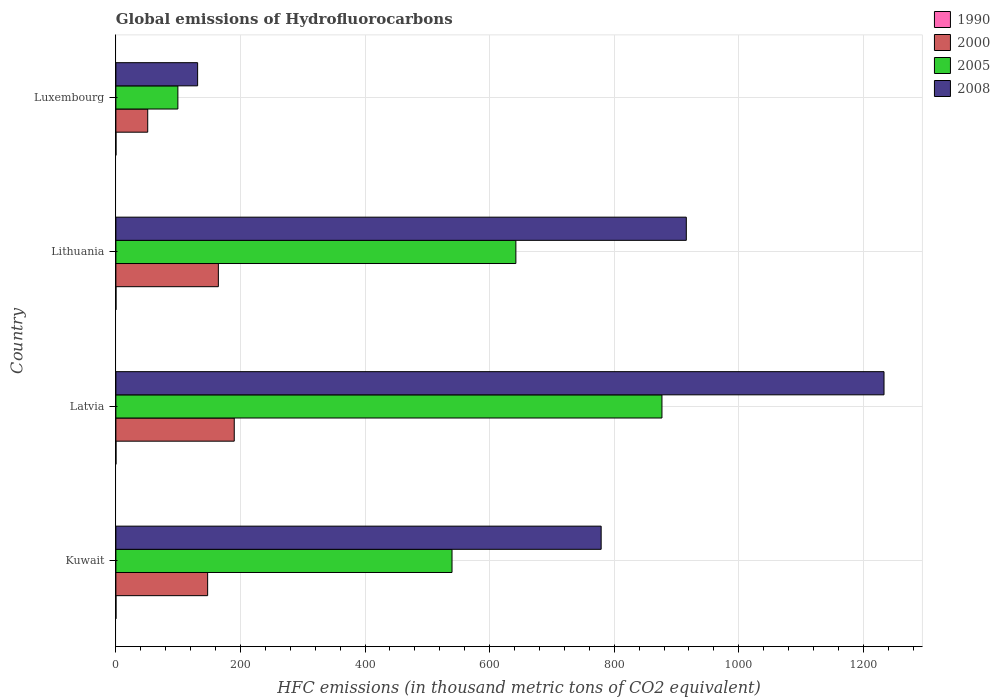How many different coloured bars are there?
Offer a very short reply. 4. Are the number of bars per tick equal to the number of legend labels?
Your answer should be very brief. Yes. How many bars are there on the 4th tick from the bottom?
Provide a short and direct response. 4. What is the label of the 3rd group of bars from the top?
Offer a terse response. Latvia. What is the global emissions of Hydrofluorocarbons in 2008 in Lithuania?
Offer a very short reply. 915.7. In which country was the global emissions of Hydrofluorocarbons in 1990 maximum?
Keep it short and to the point. Kuwait. In which country was the global emissions of Hydrofluorocarbons in 2000 minimum?
Your answer should be very brief. Luxembourg. What is the total global emissions of Hydrofluorocarbons in 2000 in the graph?
Keep it short and to the point. 552.9. What is the difference between the global emissions of Hydrofluorocarbons in 2000 in Lithuania and that in Luxembourg?
Make the answer very short. 113.4. What is the difference between the global emissions of Hydrofluorocarbons in 1990 in Kuwait and the global emissions of Hydrofluorocarbons in 2008 in Luxembourg?
Ensure brevity in your answer.  -131.1. What is the average global emissions of Hydrofluorocarbons in 1990 per country?
Keep it short and to the point. 0.1. What is the difference between the global emissions of Hydrofluorocarbons in 2008 and global emissions of Hydrofluorocarbons in 2005 in Lithuania?
Provide a succinct answer. 273.6. In how many countries, is the global emissions of Hydrofluorocarbons in 2008 greater than 240 thousand metric tons?
Your response must be concise. 3. What is the ratio of the global emissions of Hydrofluorocarbons in 2000 in Kuwait to that in Latvia?
Offer a very short reply. 0.78. Is the global emissions of Hydrofluorocarbons in 2000 in Latvia less than that in Luxembourg?
Keep it short and to the point. No. Is the difference between the global emissions of Hydrofluorocarbons in 2008 in Lithuania and Luxembourg greater than the difference between the global emissions of Hydrofluorocarbons in 2005 in Lithuania and Luxembourg?
Keep it short and to the point. Yes. What is the difference between the highest and the second highest global emissions of Hydrofluorocarbons in 2008?
Offer a very short reply. 317.4. What is the difference between the highest and the lowest global emissions of Hydrofluorocarbons in 2008?
Your answer should be very brief. 1101.9. In how many countries, is the global emissions of Hydrofluorocarbons in 1990 greater than the average global emissions of Hydrofluorocarbons in 1990 taken over all countries?
Offer a terse response. 0. Is the sum of the global emissions of Hydrofluorocarbons in 2005 in Latvia and Lithuania greater than the maximum global emissions of Hydrofluorocarbons in 2000 across all countries?
Ensure brevity in your answer.  Yes. What does the 1st bar from the bottom in Kuwait represents?
Offer a terse response. 1990. How many countries are there in the graph?
Provide a short and direct response. 4. What is the difference between two consecutive major ticks on the X-axis?
Your answer should be very brief. 200. Are the values on the major ticks of X-axis written in scientific E-notation?
Provide a succinct answer. No. Does the graph contain any zero values?
Ensure brevity in your answer.  No. Does the graph contain grids?
Keep it short and to the point. Yes. How many legend labels are there?
Make the answer very short. 4. What is the title of the graph?
Ensure brevity in your answer.  Global emissions of Hydrofluorocarbons. What is the label or title of the X-axis?
Provide a succinct answer. HFC emissions (in thousand metric tons of CO2 equivalent). What is the HFC emissions (in thousand metric tons of CO2 equivalent) in 1990 in Kuwait?
Make the answer very short. 0.1. What is the HFC emissions (in thousand metric tons of CO2 equivalent) of 2000 in Kuwait?
Provide a short and direct response. 147.3. What is the HFC emissions (in thousand metric tons of CO2 equivalent) in 2005 in Kuwait?
Offer a terse response. 539.6. What is the HFC emissions (in thousand metric tons of CO2 equivalent) of 2008 in Kuwait?
Give a very brief answer. 779. What is the HFC emissions (in thousand metric tons of CO2 equivalent) of 2000 in Latvia?
Your answer should be very brief. 190. What is the HFC emissions (in thousand metric tons of CO2 equivalent) of 2005 in Latvia?
Keep it short and to the point. 876.6. What is the HFC emissions (in thousand metric tons of CO2 equivalent) of 2008 in Latvia?
Offer a terse response. 1233.1. What is the HFC emissions (in thousand metric tons of CO2 equivalent) in 1990 in Lithuania?
Provide a short and direct response. 0.1. What is the HFC emissions (in thousand metric tons of CO2 equivalent) of 2000 in Lithuania?
Offer a terse response. 164.5. What is the HFC emissions (in thousand metric tons of CO2 equivalent) in 2005 in Lithuania?
Provide a short and direct response. 642.1. What is the HFC emissions (in thousand metric tons of CO2 equivalent) in 2008 in Lithuania?
Provide a succinct answer. 915.7. What is the HFC emissions (in thousand metric tons of CO2 equivalent) in 2000 in Luxembourg?
Keep it short and to the point. 51.1. What is the HFC emissions (in thousand metric tons of CO2 equivalent) of 2005 in Luxembourg?
Your response must be concise. 99.5. What is the HFC emissions (in thousand metric tons of CO2 equivalent) of 2008 in Luxembourg?
Provide a succinct answer. 131.2. Across all countries, what is the maximum HFC emissions (in thousand metric tons of CO2 equivalent) in 1990?
Give a very brief answer. 0.1. Across all countries, what is the maximum HFC emissions (in thousand metric tons of CO2 equivalent) in 2000?
Keep it short and to the point. 190. Across all countries, what is the maximum HFC emissions (in thousand metric tons of CO2 equivalent) of 2005?
Keep it short and to the point. 876.6. Across all countries, what is the maximum HFC emissions (in thousand metric tons of CO2 equivalent) in 2008?
Provide a succinct answer. 1233.1. Across all countries, what is the minimum HFC emissions (in thousand metric tons of CO2 equivalent) in 2000?
Your answer should be very brief. 51.1. Across all countries, what is the minimum HFC emissions (in thousand metric tons of CO2 equivalent) of 2005?
Give a very brief answer. 99.5. Across all countries, what is the minimum HFC emissions (in thousand metric tons of CO2 equivalent) in 2008?
Your answer should be compact. 131.2. What is the total HFC emissions (in thousand metric tons of CO2 equivalent) of 1990 in the graph?
Offer a terse response. 0.4. What is the total HFC emissions (in thousand metric tons of CO2 equivalent) of 2000 in the graph?
Your answer should be compact. 552.9. What is the total HFC emissions (in thousand metric tons of CO2 equivalent) of 2005 in the graph?
Ensure brevity in your answer.  2157.8. What is the total HFC emissions (in thousand metric tons of CO2 equivalent) in 2008 in the graph?
Give a very brief answer. 3059. What is the difference between the HFC emissions (in thousand metric tons of CO2 equivalent) of 2000 in Kuwait and that in Latvia?
Provide a succinct answer. -42.7. What is the difference between the HFC emissions (in thousand metric tons of CO2 equivalent) in 2005 in Kuwait and that in Latvia?
Your response must be concise. -337. What is the difference between the HFC emissions (in thousand metric tons of CO2 equivalent) in 2008 in Kuwait and that in Latvia?
Your answer should be very brief. -454.1. What is the difference between the HFC emissions (in thousand metric tons of CO2 equivalent) in 1990 in Kuwait and that in Lithuania?
Offer a very short reply. 0. What is the difference between the HFC emissions (in thousand metric tons of CO2 equivalent) of 2000 in Kuwait and that in Lithuania?
Keep it short and to the point. -17.2. What is the difference between the HFC emissions (in thousand metric tons of CO2 equivalent) of 2005 in Kuwait and that in Lithuania?
Your answer should be very brief. -102.5. What is the difference between the HFC emissions (in thousand metric tons of CO2 equivalent) of 2008 in Kuwait and that in Lithuania?
Offer a terse response. -136.7. What is the difference between the HFC emissions (in thousand metric tons of CO2 equivalent) of 2000 in Kuwait and that in Luxembourg?
Offer a terse response. 96.2. What is the difference between the HFC emissions (in thousand metric tons of CO2 equivalent) in 2005 in Kuwait and that in Luxembourg?
Your answer should be very brief. 440.1. What is the difference between the HFC emissions (in thousand metric tons of CO2 equivalent) in 2008 in Kuwait and that in Luxembourg?
Your answer should be compact. 647.8. What is the difference between the HFC emissions (in thousand metric tons of CO2 equivalent) in 2005 in Latvia and that in Lithuania?
Your answer should be very brief. 234.5. What is the difference between the HFC emissions (in thousand metric tons of CO2 equivalent) in 2008 in Latvia and that in Lithuania?
Your response must be concise. 317.4. What is the difference between the HFC emissions (in thousand metric tons of CO2 equivalent) of 2000 in Latvia and that in Luxembourg?
Ensure brevity in your answer.  138.9. What is the difference between the HFC emissions (in thousand metric tons of CO2 equivalent) of 2005 in Latvia and that in Luxembourg?
Give a very brief answer. 777.1. What is the difference between the HFC emissions (in thousand metric tons of CO2 equivalent) in 2008 in Latvia and that in Luxembourg?
Provide a succinct answer. 1101.9. What is the difference between the HFC emissions (in thousand metric tons of CO2 equivalent) of 2000 in Lithuania and that in Luxembourg?
Ensure brevity in your answer.  113.4. What is the difference between the HFC emissions (in thousand metric tons of CO2 equivalent) in 2005 in Lithuania and that in Luxembourg?
Make the answer very short. 542.6. What is the difference between the HFC emissions (in thousand metric tons of CO2 equivalent) in 2008 in Lithuania and that in Luxembourg?
Ensure brevity in your answer.  784.5. What is the difference between the HFC emissions (in thousand metric tons of CO2 equivalent) in 1990 in Kuwait and the HFC emissions (in thousand metric tons of CO2 equivalent) in 2000 in Latvia?
Keep it short and to the point. -189.9. What is the difference between the HFC emissions (in thousand metric tons of CO2 equivalent) of 1990 in Kuwait and the HFC emissions (in thousand metric tons of CO2 equivalent) of 2005 in Latvia?
Ensure brevity in your answer.  -876.5. What is the difference between the HFC emissions (in thousand metric tons of CO2 equivalent) of 1990 in Kuwait and the HFC emissions (in thousand metric tons of CO2 equivalent) of 2008 in Latvia?
Offer a terse response. -1233. What is the difference between the HFC emissions (in thousand metric tons of CO2 equivalent) of 2000 in Kuwait and the HFC emissions (in thousand metric tons of CO2 equivalent) of 2005 in Latvia?
Your answer should be very brief. -729.3. What is the difference between the HFC emissions (in thousand metric tons of CO2 equivalent) in 2000 in Kuwait and the HFC emissions (in thousand metric tons of CO2 equivalent) in 2008 in Latvia?
Offer a very short reply. -1085.8. What is the difference between the HFC emissions (in thousand metric tons of CO2 equivalent) of 2005 in Kuwait and the HFC emissions (in thousand metric tons of CO2 equivalent) of 2008 in Latvia?
Your answer should be very brief. -693.5. What is the difference between the HFC emissions (in thousand metric tons of CO2 equivalent) in 1990 in Kuwait and the HFC emissions (in thousand metric tons of CO2 equivalent) in 2000 in Lithuania?
Your response must be concise. -164.4. What is the difference between the HFC emissions (in thousand metric tons of CO2 equivalent) in 1990 in Kuwait and the HFC emissions (in thousand metric tons of CO2 equivalent) in 2005 in Lithuania?
Your answer should be compact. -642. What is the difference between the HFC emissions (in thousand metric tons of CO2 equivalent) of 1990 in Kuwait and the HFC emissions (in thousand metric tons of CO2 equivalent) of 2008 in Lithuania?
Your answer should be very brief. -915.6. What is the difference between the HFC emissions (in thousand metric tons of CO2 equivalent) of 2000 in Kuwait and the HFC emissions (in thousand metric tons of CO2 equivalent) of 2005 in Lithuania?
Keep it short and to the point. -494.8. What is the difference between the HFC emissions (in thousand metric tons of CO2 equivalent) of 2000 in Kuwait and the HFC emissions (in thousand metric tons of CO2 equivalent) of 2008 in Lithuania?
Provide a succinct answer. -768.4. What is the difference between the HFC emissions (in thousand metric tons of CO2 equivalent) in 2005 in Kuwait and the HFC emissions (in thousand metric tons of CO2 equivalent) in 2008 in Lithuania?
Give a very brief answer. -376.1. What is the difference between the HFC emissions (in thousand metric tons of CO2 equivalent) in 1990 in Kuwait and the HFC emissions (in thousand metric tons of CO2 equivalent) in 2000 in Luxembourg?
Your answer should be compact. -51. What is the difference between the HFC emissions (in thousand metric tons of CO2 equivalent) in 1990 in Kuwait and the HFC emissions (in thousand metric tons of CO2 equivalent) in 2005 in Luxembourg?
Keep it short and to the point. -99.4. What is the difference between the HFC emissions (in thousand metric tons of CO2 equivalent) of 1990 in Kuwait and the HFC emissions (in thousand metric tons of CO2 equivalent) of 2008 in Luxembourg?
Provide a succinct answer. -131.1. What is the difference between the HFC emissions (in thousand metric tons of CO2 equivalent) in 2000 in Kuwait and the HFC emissions (in thousand metric tons of CO2 equivalent) in 2005 in Luxembourg?
Offer a terse response. 47.8. What is the difference between the HFC emissions (in thousand metric tons of CO2 equivalent) of 2000 in Kuwait and the HFC emissions (in thousand metric tons of CO2 equivalent) of 2008 in Luxembourg?
Provide a succinct answer. 16.1. What is the difference between the HFC emissions (in thousand metric tons of CO2 equivalent) in 2005 in Kuwait and the HFC emissions (in thousand metric tons of CO2 equivalent) in 2008 in Luxembourg?
Keep it short and to the point. 408.4. What is the difference between the HFC emissions (in thousand metric tons of CO2 equivalent) of 1990 in Latvia and the HFC emissions (in thousand metric tons of CO2 equivalent) of 2000 in Lithuania?
Offer a terse response. -164.4. What is the difference between the HFC emissions (in thousand metric tons of CO2 equivalent) of 1990 in Latvia and the HFC emissions (in thousand metric tons of CO2 equivalent) of 2005 in Lithuania?
Offer a terse response. -642. What is the difference between the HFC emissions (in thousand metric tons of CO2 equivalent) in 1990 in Latvia and the HFC emissions (in thousand metric tons of CO2 equivalent) in 2008 in Lithuania?
Provide a succinct answer. -915.6. What is the difference between the HFC emissions (in thousand metric tons of CO2 equivalent) of 2000 in Latvia and the HFC emissions (in thousand metric tons of CO2 equivalent) of 2005 in Lithuania?
Offer a terse response. -452.1. What is the difference between the HFC emissions (in thousand metric tons of CO2 equivalent) in 2000 in Latvia and the HFC emissions (in thousand metric tons of CO2 equivalent) in 2008 in Lithuania?
Give a very brief answer. -725.7. What is the difference between the HFC emissions (in thousand metric tons of CO2 equivalent) in 2005 in Latvia and the HFC emissions (in thousand metric tons of CO2 equivalent) in 2008 in Lithuania?
Offer a terse response. -39.1. What is the difference between the HFC emissions (in thousand metric tons of CO2 equivalent) of 1990 in Latvia and the HFC emissions (in thousand metric tons of CO2 equivalent) of 2000 in Luxembourg?
Keep it short and to the point. -51. What is the difference between the HFC emissions (in thousand metric tons of CO2 equivalent) of 1990 in Latvia and the HFC emissions (in thousand metric tons of CO2 equivalent) of 2005 in Luxembourg?
Offer a terse response. -99.4. What is the difference between the HFC emissions (in thousand metric tons of CO2 equivalent) of 1990 in Latvia and the HFC emissions (in thousand metric tons of CO2 equivalent) of 2008 in Luxembourg?
Offer a terse response. -131.1. What is the difference between the HFC emissions (in thousand metric tons of CO2 equivalent) of 2000 in Latvia and the HFC emissions (in thousand metric tons of CO2 equivalent) of 2005 in Luxembourg?
Your answer should be compact. 90.5. What is the difference between the HFC emissions (in thousand metric tons of CO2 equivalent) in 2000 in Latvia and the HFC emissions (in thousand metric tons of CO2 equivalent) in 2008 in Luxembourg?
Offer a very short reply. 58.8. What is the difference between the HFC emissions (in thousand metric tons of CO2 equivalent) in 2005 in Latvia and the HFC emissions (in thousand metric tons of CO2 equivalent) in 2008 in Luxembourg?
Your response must be concise. 745.4. What is the difference between the HFC emissions (in thousand metric tons of CO2 equivalent) in 1990 in Lithuania and the HFC emissions (in thousand metric tons of CO2 equivalent) in 2000 in Luxembourg?
Your response must be concise. -51. What is the difference between the HFC emissions (in thousand metric tons of CO2 equivalent) of 1990 in Lithuania and the HFC emissions (in thousand metric tons of CO2 equivalent) of 2005 in Luxembourg?
Your answer should be very brief. -99.4. What is the difference between the HFC emissions (in thousand metric tons of CO2 equivalent) of 1990 in Lithuania and the HFC emissions (in thousand metric tons of CO2 equivalent) of 2008 in Luxembourg?
Ensure brevity in your answer.  -131.1. What is the difference between the HFC emissions (in thousand metric tons of CO2 equivalent) in 2000 in Lithuania and the HFC emissions (in thousand metric tons of CO2 equivalent) in 2008 in Luxembourg?
Your response must be concise. 33.3. What is the difference between the HFC emissions (in thousand metric tons of CO2 equivalent) of 2005 in Lithuania and the HFC emissions (in thousand metric tons of CO2 equivalent) of 2008 in Luxembourg?
Make the answer very short. 510.9. What is the average HFC emissions (in thousand metric tons of CO2 equivalent) of 2000 per country?
Keep it short and to the point. 138.22. What is the average HFC emissions (in thousand metric tons of CO2 equivalent) of 2005 per country?
Offer a very short reply. 539.45. What is the average HFC emissions (in thousand metric tons of CO2 equivalent) of 2008 per country?
Make the answer very short. 764.75. What is the difference between the HFC emissions (in thousand metric tons of CO2 equivalent) of 1990 and HFC emissions (in thousand metric tons of CO2 equivalent) of 2000 in Kuwait?
Provide a succinct answer. -147.2. What is the difference between the HFC emissions (in thousand metric tons of CO2 equivalent) of 1990 and HFC emissions (in thousand metric tons of CO2 equivalent) of 2005 in Kuwait?
Offer a terse response. -539.5. What is the difference between the HFC emissions (in thousand metric tons of CO2 equivalent) in 1990 and HFC emissions (in thousand metric tons of CO2 equivalent) in 2008 in Kuwait?
Make the answer very short. -778.9. What is the difference between the HFC emissions (in thousand metric tons of CO2 equivalent) in 2000 and HFC emissions (in thousand metric tons of CO2 equivalent) in 2005 in Kuwait?
Keep it short and to the point. -392.3. What is the difference between the HFC emissions (in thousand metric tons of CO2 equivalent) in 2000 and HFC emissions (in thousand metric tons of CO2 equivalent) in 2008 in Kuwait?
Offer a very short reply. -631.7. What is the difference between the HFC emissions (in thousand metric tons of CO2 equivalent) of 2005 and HFC emissions (in thousand metric tons of CO2 equivalent) of 2008 in Kuwait?
Make the answer very short. -239.4. What is the difference between the HFC emissions (in thousand metric tons of CO2 equivalent) in 1990 and HFC emissions (in thousand metric tons of CO2 equivalent) in 2000 in Latvia?
Your answer should be very brief. -189.9. What is the difference between the HFC emissions (in thousand metric tons of CO2 equivalent) of 1990 and HFC emissions (in thousand metric tons of CO2 equivalent) of 2005 in Latvia?
Your answer should be very brief. -876.5. What is the difference between the HFC emissions (in thousand metric tons of CO2 equivalent) in 1990 and HFC emissions (in thousand metric tons of CO2 equivalent) in 2008 in Latvia?
Ensure brevity in your answer.  -1233. What is the difference between the HFC emissions (in thousand metric tons of CO2 equivalent) in 2000 and HFC emissions (in thousand metric tons of CO2 equivalent) in 2005 in Latvia?
Your response must be concise. -686.6. What is the difference between the HFC emissions (in thousand metric tons of CO2 equivalent) in 2000 and HFC emissions (in thousand metric tons of CO2 equivalent) in 2008 in Latvia?
Provide a short and direct response. -1043.1. What is the difference between the HFC emissions (in thousand metric tons of CO2 equivalent) of 2005 and HFC emissions (in thousand metric tons of CO2 equivalent) of 2008 in Latvia?
Provide a succinct answer. -356.5. What is the difference between the HFC emissions (in thousand metric tons of CO2 equivalent) in 1990 and HFC emissions (in thousand metric tons of CO2 equivalent) in 2000 in Lithuania?
Your answer should be very brief. -164.4. What is the difference between the HFC emissions (in thousand metric tons of CO2 equivalent) of 1990 and HFC emissions (in thousand metric tons of CO2 equivalent) of 2005 in Lithuania?
Offer a very short reply. -642. What is the difference between the HFC emissions (in thousand metric tons of CO2 equivalent) in 1990 and HFC emissions (in thousand metric tons of CO2 equivalent) in 2008 in Lithuania?
Your answer should be compact. -915.6. What is the difference between the HFC emissions (in thousand metric tons of CO2 equivalent) of 2000 and HFC emissions (in thousand metric tons of CO2 equivalent) of 2005 in Lithuania?
Your response must be concise. -477.6. What is the difference between the HFC emissions (in thousand metric tons of CO2 equivalent) of 2000 and HFC emissions (in thousand metric tons of CO2 equivalent) of 2008 in Lithuania?
Make the answer very short. -751.2. What is the difference between the HFC emissions (in thousand metric tons of CO2 equivalent) of 2005 and HFC emissions (in thousand metric tons of CO2 equivalent) of 2008 in Lithuania?
Offer a terse response. -273.6. What is the difference between the HFC emissions (in thousand metric tons of CO2 equivalent) of 1990 and HFC emissions (in thousand metric tons of CO2 equivalent) of 2000 in Luxembourg?
Ensure brevity in your answer.  -51. What is the difference between the HFC emissions (in thousand metric tons of CO2 equivalent) in 1990 and HFC emissions (in thousand metric tons of CO2 equivalent) in 2005 in Luxembourg?
Offer a very short reply. -99.4. What is the difference between the HFC emissions (in thousand metric tons of CO2 equivalent) of 1990 and HFC emissions (in thousand metric tons of CO2 equivalent) of 2008 in Luxembourg?
Give a very brief answer. -131.1. What is the difference between the HFC emissions (in thousand metric tons of CO2 equivalent) in 2000 and HFC emissions (in thousand metric tons of CO2 equivalent) in 2005 in Luxembourg?
Make the answer very short. -48.4. What is the difference between the HFC emissions (in thousand metric tons of CO2 equivalent) of 2000 and HFC emissions (in thousand metric tons of CO2 equivalent) of 2008 in Luxembourg?
Ensure brevity in your answer.  -80.1. What is the difference between the HFC emissions (in thousand metric tons of CO2 equivalent) of 2005 and HFC emissions (in thousand metric tons of CO2 equivalent) of 2008 in Luxembourg?
Give a very brief answer. -31.7. What is the ratio of the HFC emissions (in thousand metric tons of CO2 equivalent) of 2000 in Kuwait to that in Latvia?
Keep it short and to the point. 0.78. What is the ratio of the HFC emissions (in thousand metric tons of CO2 equivalent) in 2005 in Kuwait to that in Latvia?
Provide a short and direct response. 0.62. What is the ratio of the HFC emissions (in thousand metric tons of CO2 equivalent) of 2008 in Kuwait to that in Latvia?
Give a very brief answer. 0.63. What is the ratio of the HFC emissions (in thousand metric tons of CO2 equivalent) of 1990 in Kuwait to that in Lithuania?
Provide a succinct answer. 1. What is the ratio of the HFC emissions (in thousand metric tons of CO2 equivalent) in 2000 in Kuwait to that in Lithuania?
Your answer should be very brief. 0.9. What is the ratio of the HFC emissions (in thousand metric tons of CO2 equivalent) of 2005 in Kuwait to that in Lithuania?
Provide a succinct answer. 0.84. What is the ratio of the HFC emissions (in thousand metric tons of CO2 equivalent) in 2008 in Kuwait to that in Lithuania?
Make the answer very short. 0.85. What is the ratio of the HFC emissions (in thousand metric tons of CO2 equivalent) in 2000 in Kuwait to that in Luxembourg?
Offer a very short reply. 2.88. What is the ratio of the HFC emissions (in thousand metric tons of CO2 equivalent) of 2005 in Kuwait to that in Luxembourg?
Your response must be concise. 5.42. What is the ratio of the HFC emissions (in thousand metric tons of CO2 equivalent) of 2008 in Kuwait to that in Luxembourg?
Keep it short and to the point. 5.94. What is the ratio of the HFC emissions (in thousand metric tons of CO2 equivalent) in 1990 in Latvia to that in Lithuania?
Your answer should be compact. 1. What is the ratio of the HFC emissions (in thousand metric tons of CO2 equivalent) in 2000 in Latvia to that in Lithuania?
Offer a terse response. 1.16. What is the ratio of the HFC emissions (in thousand metric tons of CO2 equivalent) in 2005 in Latvia to that in Lithuania?
Keep it short and to the point. 1.37. What is the ratio of the HFC emissions (in thousand metric tons of CO2 equivalent) in 2008 in Latvia to that in Lithuania?
Offer a very short reply. 1.35. What is the ratio of the HFC emissions (in thousand metric tons of CO2 equivalent) in 1990 in Latvia to that in Luxembourg?
Offer a very short reply. 1. What is the ratio of the HFC emissions (in thousand metric tons of CO2 equivalent) of 2000 in Latvia to that in Luxembourg?
Ensure brevity in your answer.  3.72. What is the ratio of the HFC emissions (in thousand metric tons of CO2 equivalent) of 2005 in Latvia to that in Luxembourg?
Keep it short and to the point. 8.81. What is the ratio of the HFC emissions (in thousand metric tons of CO2 equivalent) of 2008 in Latvia to that in Luxembourg?
Make the answer very short. 9.4. What is the ratio of the HFC emissions (in thousand metric tons of CO2 equivalent) of 2000 in Lithuania to that in Luxembourg?
Keep it short and to the point. 3.22. What is the ratio of the HFC emissions (in thousand metric tons of CO2 equivalent) in 2005 in Lithuania to that in Luxembourg?
Give a very brief answer. 6.45. What is the ratio of the HFC emissions (in thousand metric tons of CO2 equivalent) of 2008 in Lithuania to that in Luxembourg?
Your answer should be compact. 6.98. What is the difference between the highest and the second highest HFC emissions (in thousand metric tons of CO2 equivalent) in 2005?
Your answer should be very brief. 234.5. What is the difference between the highest and the second highest HFC emissions (in thousand metric tons of CO2 equivalent) of 2008?
Provide a succinct answer. 317.4. What is the difference between the highest and the lowest HFC emissions (in thousand metric tons of CO2 equivalent) in 1990?
Provide a succinct answer. 0. What is the difference between the highest and the lowest HFC emissions (in thousand metric tons of CO2 equivalent) of 2000?
Your answer should be compact. 138.9. What is the difference between the highest and the lowest HFC emissions (in thousand metric tons of CO2 equivalent) of 2005?
Keep it short and to the point. 777.1. What is the difference between the highest and the lowest HFC emissions (in thousand metric tons of CO2 equivalent) of 2008?
Give a very brief answer. 1101.9. 